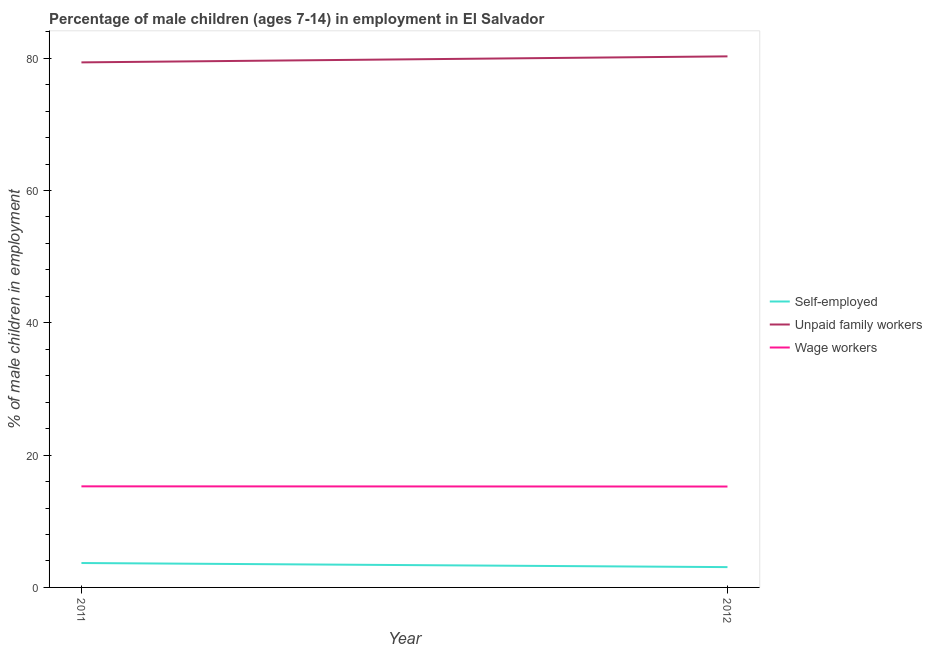Does the line corresponding to percentage of self employed children intersect with the line corresponding to percentage of children employed as wage workers?
Provide a succinct answer. No. Is the number of lines equal to the number of legend labels?
Provide a short and direct response. Yes. What is the percentage of children employed as unpaid family workers in 2011?
Give a very brief answer. 79.37. Across all years, what is the maximum percentage of children employed as unpaid family workers?
Make the answer very short. 80.28. Across all years, what is the minimum percentage of children employed as wage workers?
Your response must be concise. 15.25. What is the total percentage of children employed as wage workers in the graph?
Give a very brief answer. 30.53. What is the difference between the percentage of children employed as wage workers in 2011 and that in 2012?
Offer a terse response. 0.03. What is the difference between the percentage of self employed children in 2012 and the percentage of children employed as unpaid family workers in 2011?
Keep it short and to the point. -76.3. What is the average percentage of children employed as wage workers per year?
Your answer should be compact. 15.27. In the year 2011, what is the difference between the percentage of children employed as wage workers and percentage of children employed as unpaid family workers?
Your answer should be compact. -64.09. In how many years, is the percentage of children employed as wage workers greater than 48 %?
Your answer should be compact. 0. What is the ratio of the percentage of children employed as unpaid family workers in 2011 to that in 2012?
Your response must be concise. 0.99. Is it the case that in every year, the sum of the percentage of self employed children and percentage of children employed as unpaid family workers is greater than the percentage of children employed as wage workers?
Your response must be concise. Yes. Does the percentage of self employed children monotonically increase over the years?
Make the answer very short. No. Is the percentage of children employed as wage workers strictly less than the percentage of self employed children over the years?
Ensure brevity in your answer.  No. How many lines are there?
Keep it short and to the point. 3. Are the values on the major ticks of Y-axis written in scientific E-notation?
Provide a succinct answer. No. Does the graph contain any zero values?
Ensure brevity in your answer.  No. How many legend labels are there?
Provide a succinct answer. 3. How are the legend labels stacked?
Offer a terse response. Vertical. What is the title of the graph?
Your answer should be compact. Percentage of male children (ages 7-14) in employment in El Salvador. What is the label or title of the Y-axis?
Make the answer very short. % of male children in employment. What is the % of male children in employment of Self-employed in 2011?
Your answer should be compact. 3.69. What is the % of male children in employment of Unpaid family workers in 2011?
Provide a short and direct response. 79.37. What is the % of male children in employment in Wage workers in 2011?
Make the answer very short. 15.28. What is the % of male children in employment in Self-employed in 2012?
Keep it short and to the point. 3.07. What is the % of male children in employment in Unpaid family workers in 2012?
Provide a short and direct response. 80.28. What is the % of male children in employment of Wage workers in 2012?
Your response must be concise. 15.25. Across all years, what is the maximum % of male children in employment in Self-employed?
Your response must be concise. 3.69. Across all years, what is the maximum % of male children in employment of Unpaid family workers?
Your answer should be very brief. 80.28. Across all years, what is the maximum % of male children in employment in Wage workers?
Keep it short and to the point. 15.28. Across all years, what is the minimum % of male children in employment of Self-employed?
Provide a succinct answer. 3.07. Across all years, what is the minimum % of male children in employment in Unpaid family workers?
Provide a succinct answer. 79.37. Across all years, what is the minimum % of male children in employment of Wage workers?
Provide a succinct answer. 15.25. What is the total % of male children in employment of Self-employed in the graph?
Provide a succinct answer. 6.76. What is the total % of male children in employment in Unpaid family workers in the graph?
Provide a succinct answer. 159.65. What is the total % of male children in employment of Wage workers in the graph?
Your answer should be very brief. 30.53. What is the difference between the % of male children in employment of Self-employed in 2011 and that in 2012?
Ensure brevity in your answer.  0.62. What is the difference between the % of male children in employment of Unpaid family workers in 2011 and that in 2012?
Your answer should be compact. -0.91. What is the difference between the % of male children in employment of Self-employed in 2011 and the % of male children in employment of Unpaid family workers in 2012?
Provide a short and direct response. -76.59. What is the difference between the % of male children in employment in Self-employed in 2011 and the % of male children in employment in Wage workers in 2012?
Your response must be concise. -11.56. What is the difference between the % of male children in employment in Unpaid family workers in 2011 and the % of male children in employment in Wage workers in 2012?
Provide a succinct answer. 64.12. What is the average % of male children in employment in Self-employed per year?
Offer a very short reply. 3.38. What is the average % of male children in employment of Unpaid family workers per year?
Give a very brief answer. 79.83. What is the average % of male children in employment of Wage workers per year?
Offer a terse response. 15.27. In the year 2011, what is the difference between the % of male children in employment of Self-employed and % of male children in employment of Unpaid family workers?
Make the answer very short. -75.68. In the year 2011, what is the difference between the % of male children in employment of Self-employed and % of male children in employment of Wage workers?
Give a very brief answer. -11.59. In the year 2011, what is the difference between the % of male children in employment in Unpaid family workers and % of male children in employment in Wage workers?
Your response must be concise. 64.09. In the year 2012, what is the difference between the % of male children in employment of Self-employed and % of male children in employment of Unpaid family workers?
Make the answer very short. -77.21. In the year 2012, what is the difference between the % of male children in employment in Self-employed and % of male children in employment in Wage workers?
Offer a very short reply. -12.18. In the year 2012, what is the difference between the % of male children in employment in Unpaid family workers and % of male children in employment in Wage workers?
Your answer should be compact. 65.03. What is the ratio of the % of male children in employment of Self-employed in 2011 to that in 2012?
Provide a succinct answer. 1.2. What is the ratio of the % of male children in employment of Unpaid family workers in 2011 to that in 2012?
Keep it short and to the point. 0.99. What is the ratio of the % of male children in employment of Wage workers in 2011 to that in 2012?
Provide a short and direct response. 1. What is the difference between the highest and the second highest % of male children in employment of Self-employed?
Your response must be concise. 0.62. What is the difference between the highest and the second highest % of male children in employment of Unpaid family workers?
Offer a terse response. 0.91. What is the difference between the highest and the second highest % of male children in employment in Wage workers?
Make the answer very short. 0.03. What is the difference between the highest and the lowest % of male children in employment of Self-employed?
Your response must be concise. 0.62. What is the difference between the highest and the lowest % of male children in employment of Unpaid family workers?
Ensure brevity in your answer.  0.91. 